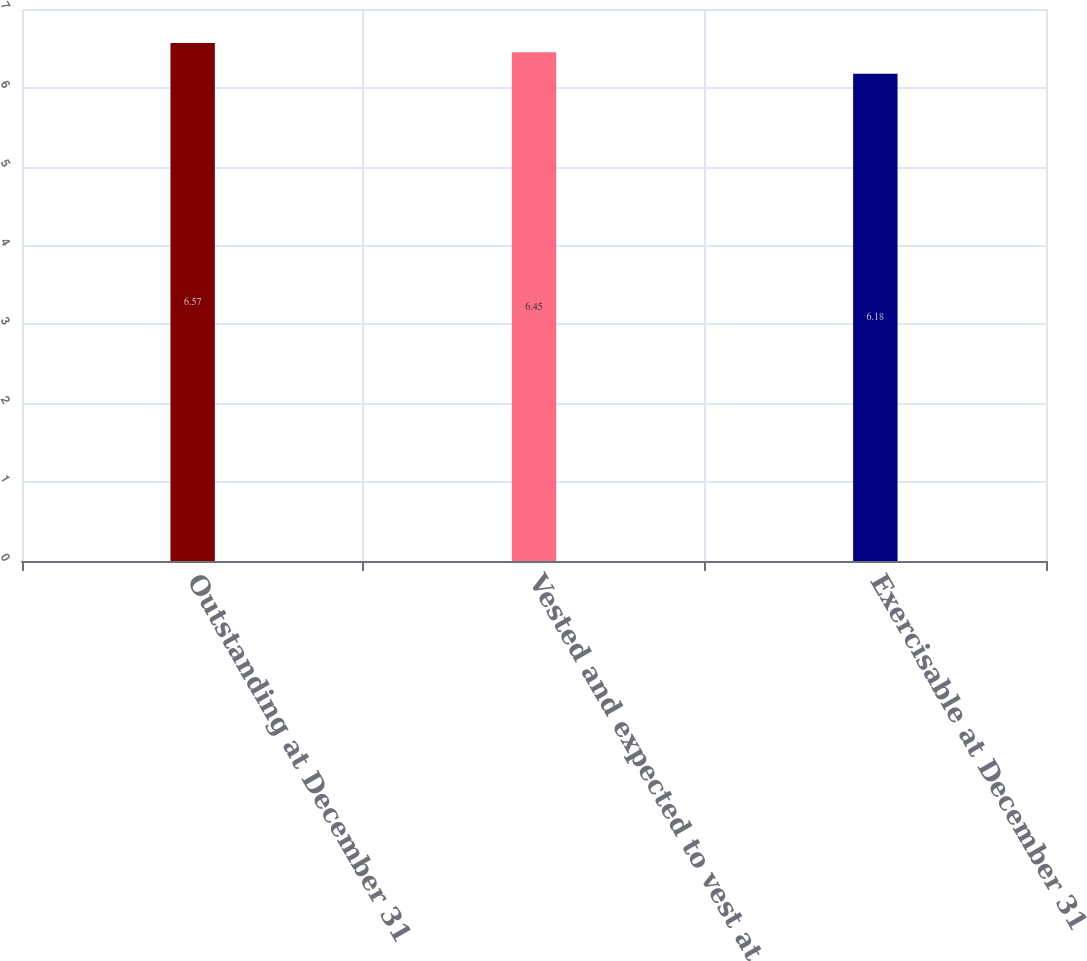Convert chart to OTSL. <chart><loc_0><loc_0><loc_500><loc_500><bar_chart><fcel>Outstanding at December 31<fcel>Vested and expected to vest at<fcel>Exercisable at December 31<nl><fcel>6.57<fcel>6.45<fcel>6.18<nl></chart> 